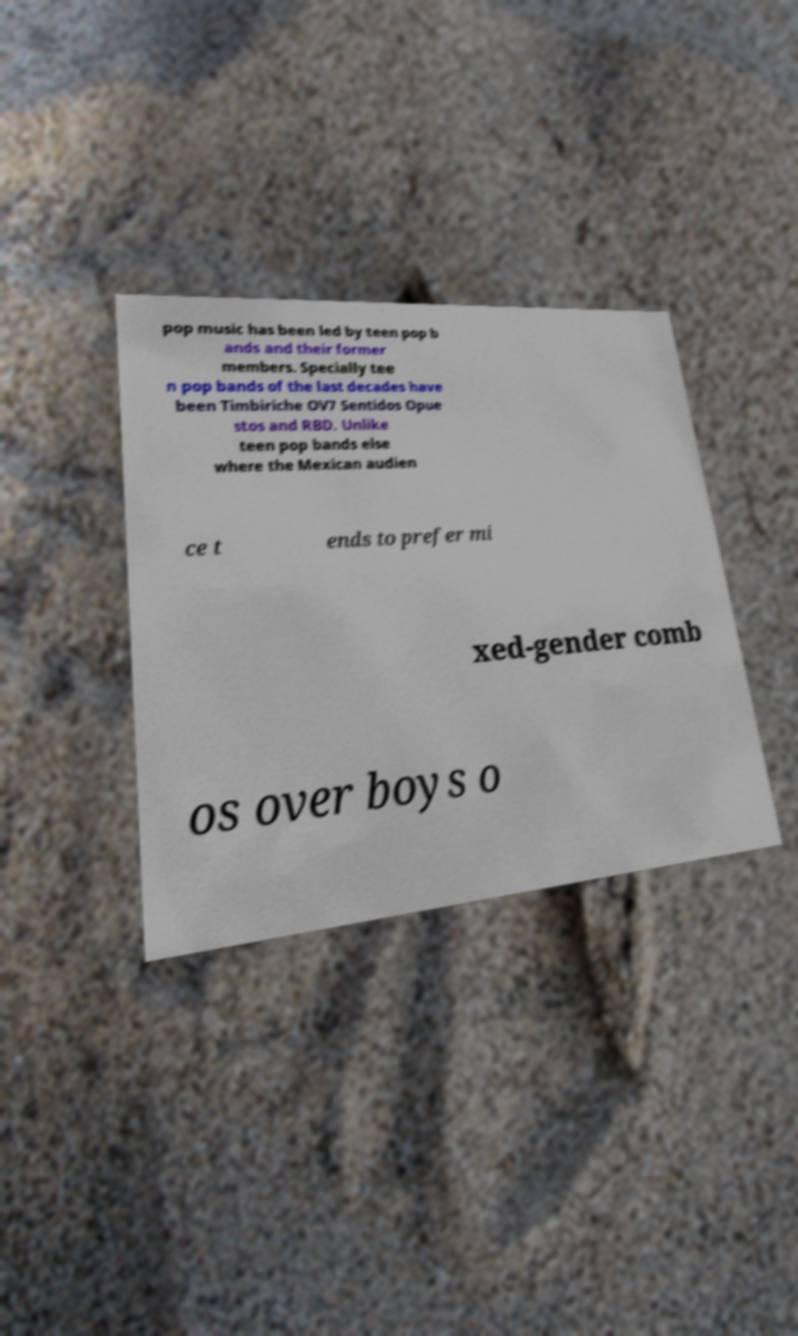Can you accurately transcribe the text from the provided image for me? pop music has been led by teen pop b ands and their former members. Specially tee n pop bands of the last decades have been Timbiriche OV7 Sentidos Opue stos and RBD. Unlike teen pop bands else where the Mexican audien ce t ends to prefer mi xed-gender comb os over boys o 